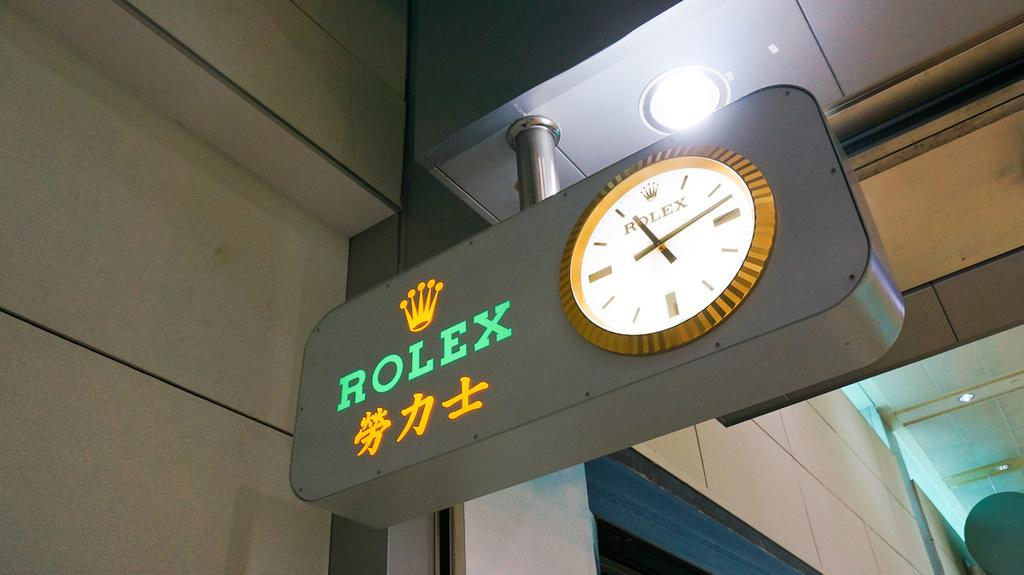<image>
Render a clear and concise summary of the photo. Rolex roman numeral clock that is gold and white 